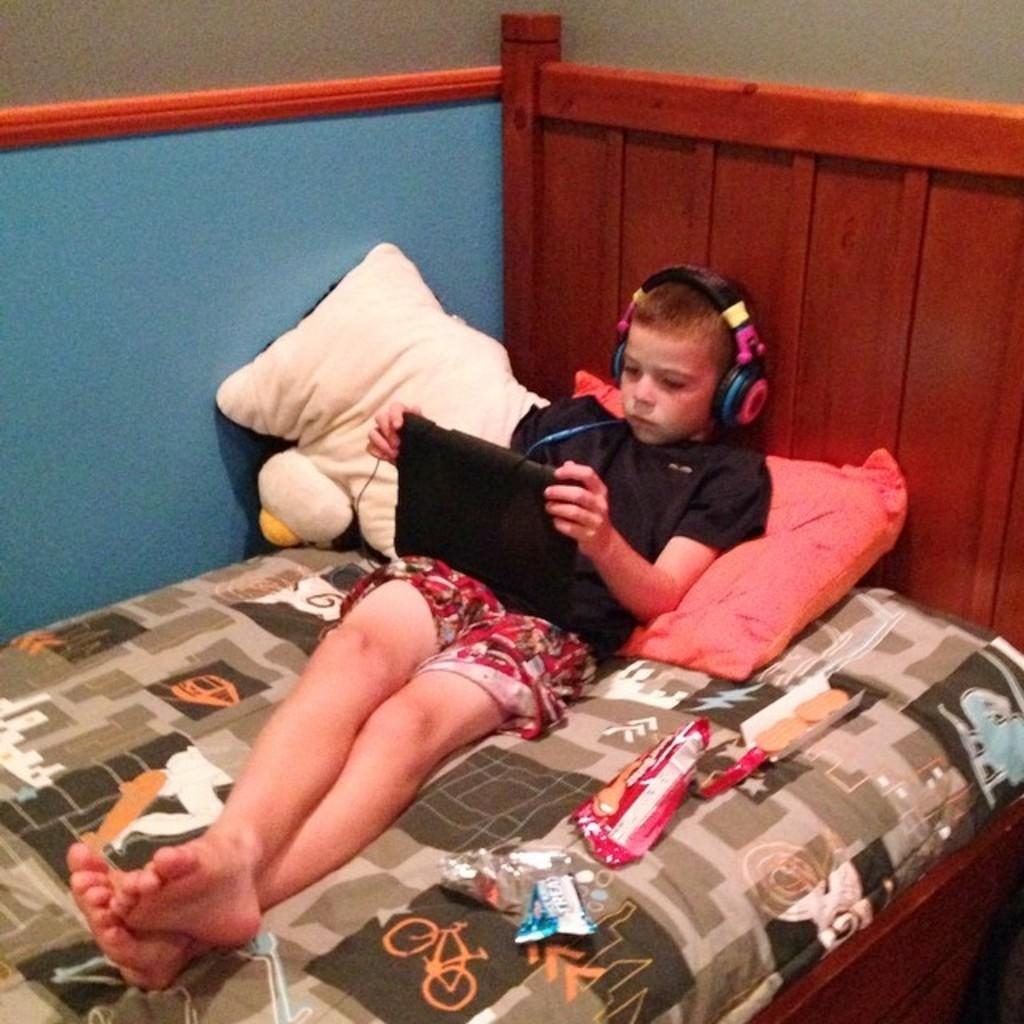What is the main subject of the picture? The main subject of the picture is a kid. What is the kid wearing in the image? The kid is wearing a black T-shirt. What is the kid doing in the image? The kid is lying on the bed. What is the kid holding in his hands? The kid is holding a tab in his hands. How many pillows are visible in the image? There are two pillows in the image. What other objects can be seen beside the kid? There are other objects beside the kid, but their specific details are not mentioned in the facts. How much money is the kid holding in the image? There is no mention of money in the image, so it cannot be determined how much the kid is holding. 